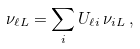Convert formula to latex. <formula><loc_0><loc_0><loc_500><loc_500>\nu _ { { \ell } L } = \sum _ { i } U _ { { \ell } i } \, \nu _ { i L } \, ,</formula> 